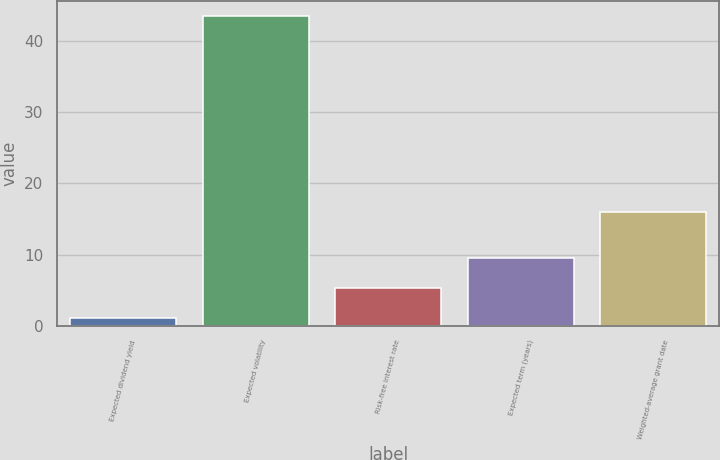<chart> <loc_0><loc_0><loc_500><loc_500><bar_chart><fcel>Expected dividend yield<fcel>Expected volatility<fcel>Risk-free interest rate<fcel>Expected term (years)<fcel>Weighted-average grant date<nl><fcel>1.09<fcel>43.43<fcel>5.32<fcel>9.55<fcel>15.96<nl></chart> 